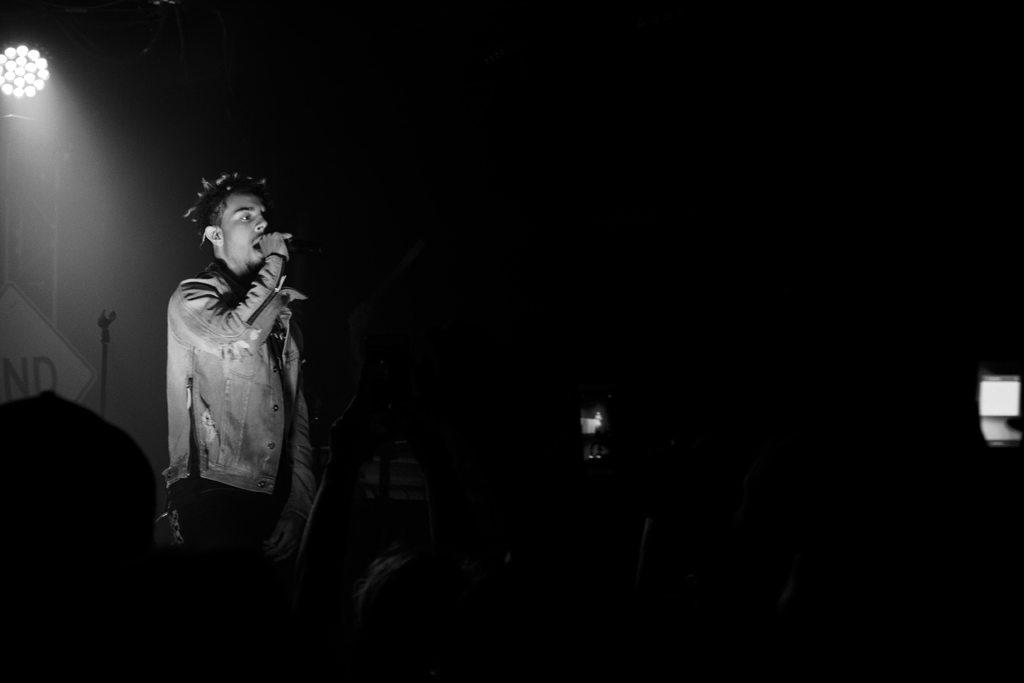How many people are in the image? There is a group of persons in the image. What are the persons in the image doing? The persons are holding objects and standing. What can be seen in the background of the image? There is a focusing light and other objects visible in the background of the image. What type of sponge is being used to gain approval in the image? There is no sponge or approval-seeking activity present in the image. What is being copied by the persons in the image? There is no copying activity depicted in the image. 